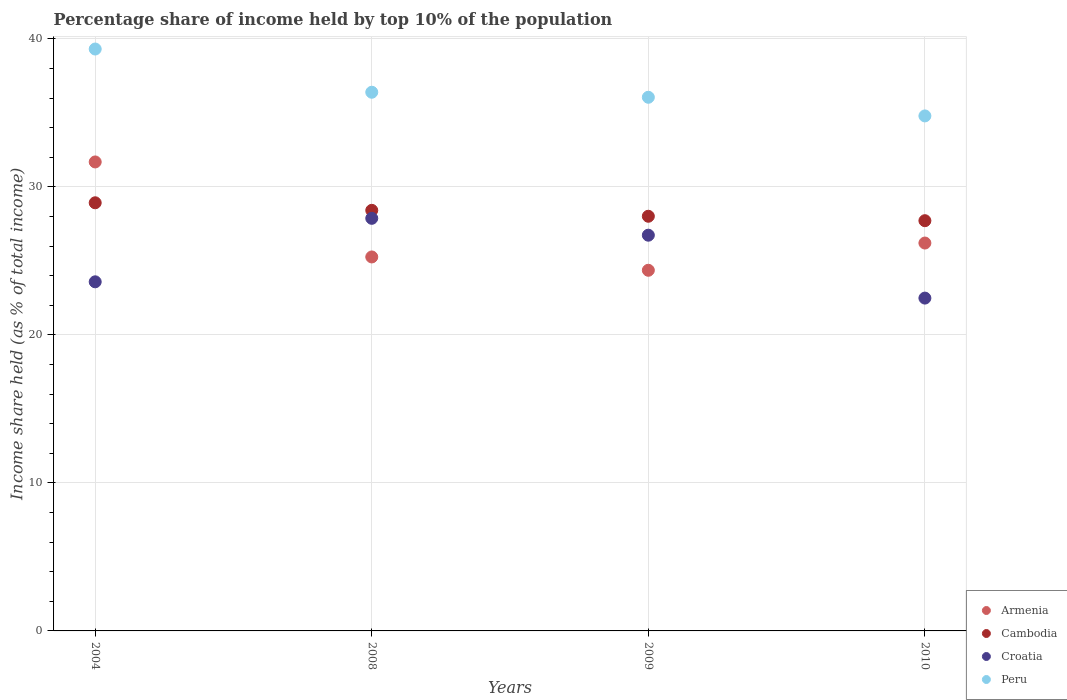How many different coloured dotlines are there?
Give a very brief answer. 4. Is the number of dotlines equal to the number of legend labels?
Provide a succinct answer. Yes. What is the percentage share of income held by top 10% of the population in Cambodia in 2004?
Provide a succinct answer. 28.93. Across all years, what is the maximum percentage share of income held by top 10% of the population in Croatia?
Offer a very short reply. 27.88. Across all years, what is the minimum percentage share of income held by top 10% of the population in Armenia?
Make the answer very short. 24.37. In which year was the percentage share of income held by top 10% of the population in Armenia maximum?
Your response must be concise. 2004. What is the total percentage share of income held by top 10% of the population in Croatia in the graph?
Your response must be concise. 100.7. What is the difference between the percentage share of income held by top 10% of the population in Peru in 2008 and that in 2009?
Ensure brevity in your answer.  0.34. What is the difference between the percentage share of income held by top 10% of the population in Peru in 2008 and the percentage share of income held by top 10% of the population in Armenia in 2010?
Offer a terse response. 10.19. What is the average percentage share of income held by top 10% of the population in Peru per year?
Your response must be concise. 36.64. In the year 2008, what is the difference between the percentage share of income held by top 10% of the population in Cambodia and percentage share of income held by top 10% of the population in Croatia?
Your answer should be very brief. 0.54. In how many years, is the percentage share of income held by top 10% of the population in Cambodia greater than 26 %?
Keep it short and to the point. 4. What is the ratio of the percentage share of income held by top 10% of the population in Armenia in 2008 to that in 2009?
Make the answer very short. 1.04. What is the difference between the highest and the second highest percentage share of income held by top 10% of the population in Cambodia?
Ensure brevity in your answer.  0.51. What is the difference between the highest and the lowest percentage share of income held by top 10% of the population in Peru?
Your answer should be compact. 4.52. Is the sum of the percentage share of income held by top 10% of the population in Croatia in 2009 and 2010 greater than the maximum percentage share of income held by top 10% of the population in Cambodia across all years?
Provide a succinct answer. Yes. Is it the case that in every year, the sum of the percentage share of income held by top 10% of the population in Croatia and percentage share of income held by top 10% of the population in Peru  is greater than the sum of percentage share of income held by top 10% of the population in Armenia and percentage share of income held by top 10% of the population in Cambodia?
Your response must be concise. Yes. How many dotlines are there?
Make the answer very short. 4. Does the graph contain any zero values?
Ensure brevity in your answer.  No. Where does the legend appear in the graph?
Your answer should be very brief. Bottom right. How many legend labels are there?
Your answer should be compact. 4. What is the title of the graph?
Offer a terse response. Percentage share of income held by top 10% of the population. What is the label or title of the Y-axis?
Provide a succinct answer. Income share held (as % of total income). What is the Income share held (as % of total income) in Armenia in 2004?
Offer a very short reply. 31.69. What is the Income share held (as % of total income) of Cambodia in 2004?
Give a very brief answer. 28.93. What is the Income share held (as % of total income) of Croatia in 2004?
Provide a short and direct response. 23.59. What is the Income share held (as % of total income) in Peru in 2004?
Provide a succinct answer. 39.32. What is the Income share held (as % of total income) of Armenia in 2008?
Make the answer very short. 25.27. What is the Income share held (as % of total income) of Cambodia in 2008?
Offer a terse response. 28.42. What is the Income share held (as % of total income) of Croatia in 2008?
Make the answer very short. 27.88. What is the Income share held (as % of total income) of Peru in 2008?
Make the answer very short. 36.4. What is the Income share held (as % of total income) of Armenia in 2009?
Your answer should be very brief. 24.37. What is the Income share held (as % of total income) of Cambodia in 2009?
Your answer should be compact. 28.02. What is the Income share held (as % of total income) in Croatia in 2009?
Your response must be concise. 26.74. What is the Income share held (as % of total income) in Peru in 2009?
Provide a short and direct response. 36.06. What is the Income share held (as % of total income) of Armenia in 2010?
Provide a succinct answer. 26.21. What is the Income share held (as % of total income) of Cambodia in 2010?
Give a very brief answer. 27.72. What is the Income share held (as % of total income) of Croatia in 2010?
Keep it short and to the point. 22.49. What is the Income share held (as % of total income) of Peru in 2010?
Provide a succinct answer. 34.8. Across all years, what is the maximum Income share held (as % of total income) in Armenia?
Offer a very short reply. 31.69. Across all years, what is the maximum Income share held (as % of total income) in Cambodia?
Your response must be concise. 28.93. Across all years, what is the maximum Income share held (as % of total income) in Croatia?
Ensure brevity in your answer.  27.88. Across all years, what is the maximum Income share held (as % of total income) of Peru?
Your answer should be very brief. 39.32. Across all years, what is the minimum Income share held (as % of total income) in Armenia?
Your answer should be very brief. 24.37. Across all years, what is the minimum Income share held (as % of total income) in Cambodia?
Give a very brief answer. 27.72. Across all years, what is the minimum Income share held (as % of total income) of Croatia?
Provide a succinct answer. 22.49. Across all years, what is the minimum Income share held (as % of total income) in Peru?
Your answer should be compact. 34.8. What is the total Income share held (as % of total income) of Armenia in the graph?
Provide a succinct answer. 107.54. What is the total Income share held (as % of total income) in Cambodia in the graph?
Offer a terse response. 113.09. What is the total Income share held (as % of total income) of Croatia in the graph?
Offer a very short reply. 100.7. What is the total Income share held (as % of total income) of Peru in the graph?
Provide a succinct answer. 146.58. What is the difference between the Income share held (as % of total income) in Armenia in 2004 and that in 2008?
Offer a very short reply. 6.42. What is the difference between the Income share held (as % of total income) in Cambodia in 2004 and that in 2008?
Provide a short and direct response. 0.51. What is the difference between the Income share held (as % of total income) in Croatia in 2004 and that in 2008?
Make the answer very short. -4.29. What is the difference between the Income share held (as % of total income) in Peru in 2004 and that in 2008?
Your answer should be very brief. 2.92. What is the difference between the Income share held (as % of total income) of Armenia in 2004 and that in 2009?
Offer a terse response. 7.32. What is the difference between the Income share held (as % of total income) of Cambodia in 2004 and that in 2009?
Provide a short and direct response. 0.91. What is the difference between the Income share held (as % of total income) in Croatia in 2004 and that in 2009?
Give a very brief answer. -3.15. What is the difference between the Income share held (as % of total income) in Peru in 2004 and that in 2009?
Keep it short and to the point. 3.26. What is the difference between the Income share held (as % of total income) in Armenia in 2004 and that in 2010?
Provide a succinct answer. 5.48. What is the difference between the Income share held (as % of total income) in Cambodia in 2004 and that in 2010?
Give a very brief answer. 1.21. What is the difference between the Income share held (as % of total income) in Croatia in 2004 and that in 2010?
Keep it short and to the point. 1.1. What is the difference between the Income share held (as % of total income) in Peru in 2004 and that in 2010?
Your answer should be very brief. 4.52. What is the difference between the Income share held (as % of total income) in Croatia in 2008 and that in 2009?
Make the answer very short. 1.14. What is the difference between the Income share held (as % of total income) of Peru in 2008 and that in 2009?
Your response must be concise. 0.34. What is the difference between the Income share held (as % of total income) of Armenia in 2008 and that in 2010?
Offer a very short reply. -0.94. What is the difference between the Income share held (as % of total income) in Cambodia in 2008 and that in 2010?
Give a very brief answer. 0.7. What is the difference between the Income share held (as % of total income) of Croatia in 2008 and that in 2010?
Your answer should be compact. 5.39. What is the difference between the Income share held (as % of total income) in Armenia in 2009 and that in 2010?
Your answer should be very brief. -1.84. What is the difference between the Income share held (as % of total income) of Croatia in 2009 and that in 2010?
Provide a succinct answer. 4.25. What is the difference between the Income share held (as % of total income) in Peru in 2009 and that in 2010?
Provide a short and direct response. 1.26. What is the difference between the Income share held (as % of total income) in Armenia in 2004 and the Income share held (as % of total income) in Cambodia in 2008?
Provide a short and direct response. 3.27. What is the difference between the Income share held (as % of total income) of Armenia in 2004 and the Income share held (as % of total income) of Croatia in 2008?
Your answer should be very brief. 3.81. What is the difference between the Income share held (as % of total income) of Armenia in 2004 and the Income share held (as % of total income) of Peru in 2008?
Ensure brevity in your answer.  -4.71. What is the difference between the Income share held (as % of total income) of Cambodia in 2004 and the Income share held (as % of total income) of Croatia in 2008?
Offer a terse response. 1.05. What is the difference between the Income share held (as % of total income) of Cambodia in 2004 and the Income share held (as % of total income) of Peru in 2008?
Your response must be concise. -7.47. What is the difference between the Income share held (as % of total income) of Croatia in 2004 and the Income share held (as % of total income) of Peru in 2008?
Offer a terse response. -12.81. What is the difference between the Income share held (as % of total income) of Armenia in 2004 and the Income share held (as % of total income) of Cambodia in 2009?
Your response must be concise. 3.67. What is the difference between the Income share held (as % of total income) of Armenia in 2004 and the Income share held (as % of total income) of Croatia in 2009?
Offer a terse response. 4.95. What is the difference between the Income share held (as % of total income) of Armenia in 2004 and the Income share held (as % of total income) of Peru in 2009?
Offer a terse response. -4.37. What is the difference between the Income share held (as % of total income) in Cambodia in 2004 and the Income share held (as % of total income) in Croatia in 2009?
Offer a terse response. 2.19. What is the difference between the Income share held (as % of total income) in Cambodia in 2004 and the Income share held (as % of total income) in Peru in 2009?
Your answer should be very brief. -7.13. What is the difference between the Income share held (as % of total income) of Croatia in 2004 and the Income share held (as % of total income) of Peru in 2009?
Ensure brevity in your answer.  -12.47. What is the difference between the Income share held (as % of total income) in Armenia in 2004 and the Income share held (as % of total income) in Cambodia in 2010?
Provide a succinct answer. 3.97. What is the difference between the Income share held (as % of total income) of Armenia in 2004 and the Income share held (as % of total income) of Croatia in 2010?
Ensure brevity in your answer.  9.2. What is the difference between the Income share held (as % of total income) in Armenia in 2004 and the Income share held (as % of total income) in Peru in 2010?
Give a very brief answer. -3.11. What is the difference between the Income share held (as % of total income) of Cambodia in 2004 and the Income share held (as % of total income) of Croatia in 2010?
Make the answer very short. 6.44. What is the difference between the Income share held (as % of total income) of Cambodia in 2004 and the Income share held (as % of total income) of Peru in 2010?
Give a very brief answer. -5.87. What is the difference between the Income share held (as % of total income) in Croatia in 2004 and the Income share held (as % of total income) in Peru in 2010?
Your answer should be compact. -11.21. What is the difference between the Income share held (as % of total income) of Armenia in 2008 and the Income share held (as % of total income) of Cambodia in 2009?
Your answer should be compact. -2.75. What is the difference between the Income share held (as % of total income) of Armenia in 2008 and the Income share held (as % of total income) of Croatia in 2009?
Provide a succinct answer. -1.47. What is the difference between the Income share held (as % of total income) in Armenia in 2008 and the Income share held (as % of total income) in Peru in 2009?
Your answer should be compact. -10.79. What is the difference between the Income share held (as % of total income) of Cambodia in 2008 and the Income share held (as % of total income) of Croatia in 2009?
Provide a short and direct response. 1.68. What is the difference between the Income share held (as % of total income) of Cambodia in 2008 and the Income share held (as % of total income) of Peru in 2009?
Provide a succinct answer. -7.64. What is the difference between the Income share held (as % of total income) in Croatia in 2008 and the Income share held (as % of total income) in Peru in 2009?
Ensure brevity in your answer.  -8.18. What is the difference between the Income share held (as % of total income) in Armenia in 2008 and the Income share held (as % of total income) in Cambodia in 2010?
Your response must be concise. -2.45. What is the difference between the Income share held (as % of total income) in Armenia in 2008 and the Income share held (as % of total income) in Croatia in 2010?
Your answer should be compact. 2.78. What is the difference between the Income share held (as % of total income) of Armenia in 2008 and the Income share held (as % of total income) of Peru in 2010?
Offer a terse response. -9.53. What is the difference between the Income share held (as % of total income) in Cambodia in 2008 and the Income share held (as % of total income) in Croatia in 2010?
Provide a succinct answer. 5.93. What is the difference between the Income share held (as % of total income) of Cambodia in 2008 and the Income share held (as % of total income) of Peru in 2010?
Your answer should be very brief. -6.38. What is the difference between the Income share held (as % of total income) in Croatia in 2008 and the Income share held (as % of total income) in Peru in 2010?
Make the answer very short. -6.92. What is the difference between the Income share held (as % of total income) in Armenia in 2009 and the Income share held (as % of total income) in Cambodia in 2010?
Give a very brief answer. -3.35. What is the difference between the Income share held (as % of total income) in Armenia in 2009 and the Income share held (as % of total income) in Croatia in 2010?
Offer a terse response. 1.88. What is the difference between the Income share held (as % of total income) in Armenia in 2009 and the Income share held (as % of total income) in Peru in 2010?
Ensure brevity in your answer.  -10.43. What is the difference between the Income share held (as % of total income) in Cambodia in 2009 and the Income share held (as % of total income) in Croatia in 2010?
Offer a very short reply. 5.53. What is the difference between the Income share held (as % of total income) in Cambodia in 2009 and the Income share held (as % of total income) in Peru in 2010?
Keep it short and to the point. -6.78. What is the difference between the Income share held (as % of total income) in Croatia in 2009 and the Income share held (as % of total income) in Peru in 2010?
Your answer should be very brief. -8.06. What is the average Income share held (as % of total income) of Armenia per year?
Provide a short and direct response. 26.89. What is the average Income share held (as % of total income) in Cambodia per year?
Offer a terse response. 28.27. What is the average Income share held (as % of total income) of Croatia per year?
Keep it short and to the point. 25.18. What is the average Income share held (as % of total income) in Peru per year?
Keep it short and to the point. 36.65. In the year 2004, what is the difference between the Income share held (as % of total income) in Armenia and Income share held (as % of total income) in Cambodia?
Give a very brief answer. 2.76. In the year 2004, what is the difference between the Income share held (as % of total income) in Armenia and Income share held (as % of total income) in Croatia?
Offer a terse response. 8.1. In the year 2004, what is the difference between the Income share held (as % of total income) of Armenia and Income share held (as % of total income) of Peru?
Your answer should be compact. -7.63. In the year 2004, what is the difference between the Income share held (as % of total income) of Cambodia and Income share held (as % of total income) of Croatia?
Your answer should be compact. 5.34. In the year 2004, what is the difference between the Income share held (as % of total income) in Cambodia and Income share held (as % of total income) in Peru?
Your answer should be very brief. -10.39. In the year 2004, what is the difference between the Income share held (as % of total income) in Croatia and Income share held (as % of total income) in Peru?
Keep it short and to the point. -15.73. In the year 2008, what is the difference between the Income share held (as % of total income) in Armenia and Income share held (as % of total income) in Cambodia?
Your answer should be compact. -3.15. In the year 2008, what is the difference between the Income share held (as % of total income) of Armenia and Income share held (as % of total income) of Croatia?
Provide a short and direct response. -2.61. In the year 2008, what is the difference between the Income share held (as % of total income) of Armenia and Income share held (as % of total income) of Peru?
Offer a very short reply. -11.13. In the year 2008, what is the difference between the Income share held (as % of total income) in Cambodia and Income share held (as % of total income) in Croatia?
Your answer should be very brief. 0.54. In the year 2008, what is the difference between the Income share held (as % of total income) of Cambodia and Income share held (as % of total income) of Peru?
Provide a short and direct response. -7.98. In the year 2008, what is the difference between the Income share held (as % of total income) of Croatia and Income share held (as % of total income) of Peru?
Your answer should be compact. -8.52. In the year 2009, what is the difference between the Income share held (as % of total income) of Armenia and Income share held (as % of total income) of Cambodia?
Make the answer very short. -3.65. In the year 2009, what is the difference between the Income share held (as % of total income) in Armenia and Income share held (as % of total income) in Croatia?
Keep it short and to the point. -2.37. In the year 2009, what is the difference between the Income share held (as % of total income) in Armenia and Income share held (as % of total income) in Peru?
Offer a terse response. -11.69. In the year 2009, what is the difference between the Income share held (as % of total income) in Cambodia and Income share held (as % of total income) in Croatia?
Make the answer very short. 1.28. In the year 2009, what is the difference between the Income share held (as % of total income) of Cambodia and Income share held (as % of total income) of Peru?
Provide a short and direct response. -8.04. In the year 2009, what is the difference between the Income share held (as % of total income) of Croatia and Income share held (as % of total income) of Peru?
Your response must be concise. -9.32. In the year 2010, what is the difference between the Income share held (as % of total income) of Armenia and Income share held (as % of total income) of Cambodia?
Your answer should be very brief. -1.51. In the year 2010, what is the difference between the Income share held (as % of total income) in Armenia and Income share held (as % of total income) in Croatia?
Ensure brevity in your answer.  3.72. In the year 2010, what is the difference between the Income share held (as % of total income) in Armenia and Income share held (as % of total income) in Peru?
Ensure brevity in your answer.  -8.59. In the year 2010, what is the difference between the Income share held (as % of total income) in Cambodia and Income share held (as % of total income) in Croatia?
Offer a terse response. 5.23. In the year 2010, what is the difference between the Income share held (as % of total income) in Cambodia and Income share held (as % of total income) in Peru?
Provide a short and direct response. -7.08. In the year 2010, what is the difference between the Income share held (as % of total income) in Croatia and Income share held (as % of total income) in Peru?
Offer a very short reply. -12.31. What is the ratio of the Income share held (as % of total income) in Armenia in 2004 to that in 2008?
Make the answer very short. 1.25. What is the ratio of the Income share held (as % of total income) of Cambodia in 2004 to that in 2008?
Offer a very short reply. 1.02. What is the ratio of the Income share held (as % of total income) in Croatia in 2004 to that in 2008?
Your answer should be very brief. 0.85. What is the ratio of the Income share held (as % of total income) in Peru in 2004 to that in 2008?
Make the answer very short. 1.08. What is the ratio of the Income share held (as % of total income) in Armenia in 2004 to that in 2009?
Give a very brief answer. 1.3. What is the ratio of the Income share held (as % of total income) of Cambodia in 2004 to that in 2009?
Offer a terse response. 1.03. What is the ratio of the Income share held (as % of total income) of Croatia in 2004 to that in 2009?
Give a very brief answer. 0.88. What is the ratio of the Income share held (as % of total income) of Peru in 2004 to that in 2009?
Your response must be concise. 1.09. What is the ratio of the Income share held (as % of total income) of Armenia in 2004 to that in 2010?
Keep it short and to the point. 1.21. What is the ratio of the Income share held (as % of total income) of Cambodia in 2004 to that in 2010?
Give a very brief answer. 1.04. What is the ratio of the Income share held (as % of total income) of Croatia in 2004 to that in 2010?
Keep it short and to the point. 1.05. What is the ratio of the Income share held (as % of total income) of Peru in 2004 to that in 2010?
Provide a succinct answer. 1.13. What is the ratio of the Income share held (as % of total income) in Armenia in 2008 to that in 2009?
Give a very brief answer. 1.04. What is the ratio of the Income share held (as % of total income) of Cambodia in 2008 to that in 2009?
Ensure brevity in your answer.  1.01. What is the ratio of the Income share held (as % of total income) in Croatia in 2008 to that in 2009?
Offer a very short reply. 1.04. What is the ratio of the Income share held (as % of total income) in Peru in 2008 to that in 2009?
Provide a succinct answer. 1.01. What is the ratio of the Income share held (as % of total income) in Armenia in 2008 to that in 2010?
Provide a succinct answer. 0.96. What is the ratio of the Income share held (as % of total income) in Cambodia in 2008 to that in 2010?
Ensure brevity in your answer.  1.03. What is the ratio of the Income share held (as % of total income) in Croatia in 2008 to that in 2010?
Make the answer very short. 1.24. What is the ratio of the Income share held (as % of total income) of Peru in 2008 to that in 2010?
Give a very brief answer. 1.05. What is the ratio of the Income share held (as % of total income) of Armenia in 2009 to that in 2010?
Offer a terse response. 0.93. What is the ratio of the Income share held (as % of total income) of Cambodia in 2009 to that in 2010?
Make the answer very short. 1.01. What is the ratio of the Income share held (as % of total income) of Croatia in 2009 to that in 2010?
Provide a short and direct response. 1.19. What is the ratio of the Income share held (as % of total income) of Peru in 2009 to that in 2010?
Offer a very short reply. 1.04. What is the difference between the highest and the second highest Income share held (as % of total income) of Armenia?
Offer a very short reply. 5.48. What is the difference between the highest and the second highest Income share held (as % of total income) in Cambodia?
Make the answer very short. 0.51. What is the difference between the highest and the second highest Income share held (as % of total income) in Croatia?
Offer a very short reply. 1.14. What is the difference between the highest and the second highest Income share held (as % of total income) of Peru?
Your answer should be very brief. 2.92. What is the difference between the highest and the lowest Income share held (as % of total income) of Armenia?
Give a very brief answer. 7.32. What is the difference between the highest and the lowest Income share held (as % of total income) of Cambodia?
Offer a very short reply. 1.21. What is the difference between the highest and the lowest Income share held (as % of total income) in Croatia?
Give a very brief answer. 5.39. What is the difference between the highest and the lowest Income share held (as % of total income) in Peru?
Keep it short and to the point. 4.52. 